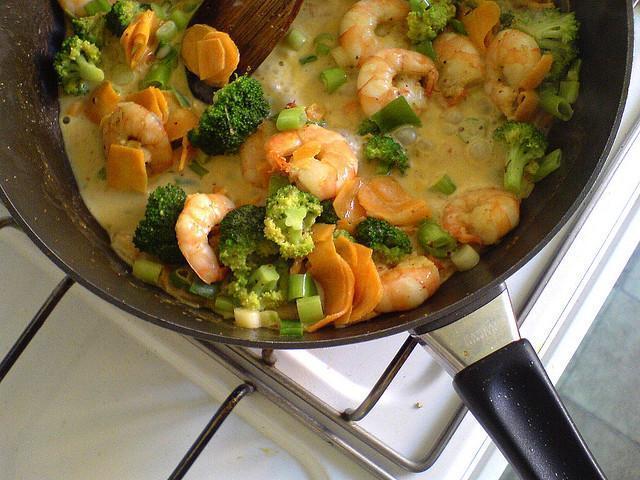How many broccolis can be seen?
Give a very brief answer. 7. How many carrots are in the picture?
Give a very brief answer. 2. How many people are supposed to sit on this?
Give a very brief answer. 0. 